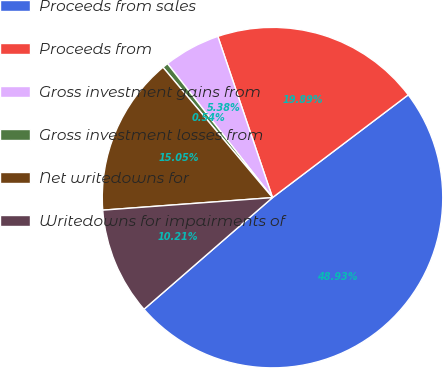Convert chart. <chart><loc_0><loc_0><loc_500><loc_500><pie_chart><fcel>Proceeds from sales<fcel>Proceeds from<fcel>Gross investment gains from<fcel>Gross investment losses from<fcel>Net writedowns for<fcel>Writedowns for impairments of<nl><fcel>48.93%<fcel>19.89%<fcel>5.38%<fcel>0.54%<fcel>15.05%<fcel>10.21%<nl></chart> 